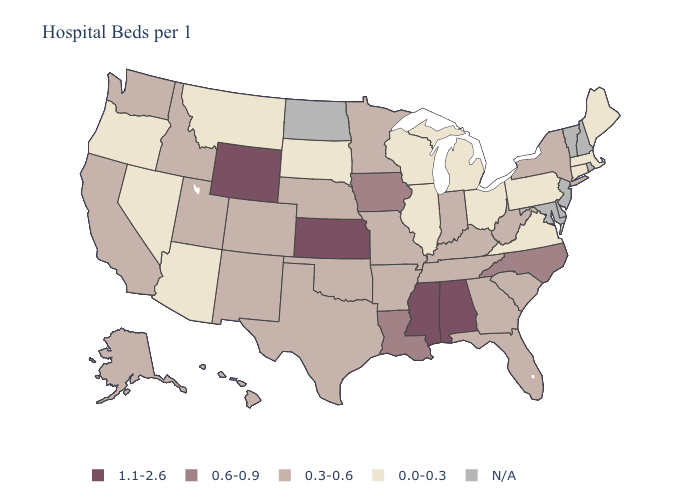What is the highest value in the Northeast ?
Write a very short answer. 0.3-0.6. Name the states that have a value in the range 1.1-2.6?
Write a very short answer. Alabama, Kansas, Mississippi, Wyoming. Which states have the highest value in the USA?
Keep it brief. Alabama, Kansas, Mississippi, Wyoming. Does Kansas have the highest value in the MidWest?
Keep it brief. Yes. Which states have the lowest value in the USA?
Concise answer only. Arizona, Connecticut, Illinois, Maine, Massachusetts, Michigan, Montana, Nevada, Ohio, Oregon, Pennsylvania, South Dakota, Virginia, Wisconsin. Name the states that have a value in the range N/A?
Give a very brief answer. Delaware, Maryland, New Hampshire, New Jersey, North Dakota, Rhode Island, Vermont. What is the highest value in the USA?
Keep it brief. 1.1-2.6. What is the value of Michigan?
Keep it brief. 0.0-0.3. Does the map have missing data?
Be succinct. Yes. Among the states that border Washington , which have the highest value?
Answer briefly. Idaho. What is the lowest value in the USA?
Answer briefly. 0.0-0.3. Name the states that have a value in the range 1.1-2.6?
Short answer required. Alabama, Kansas, Mississippi, Wyoming. What is the lowest value in the USA?
Write a very short answer. 0.0-0.3. What is the highest value in states that border Georgia?
Keep it brief. 1.1-2.6. 